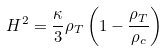Convert formula to latex. <formula><loc_0><loc_0><loc_500><loc_500>H ^ { 2 } = \frac { \kappa } { 3 } \rho _ { T } \left ( 1 - \frac { \rho _ { T } } { \rho _ { c } } \right )</formula> 